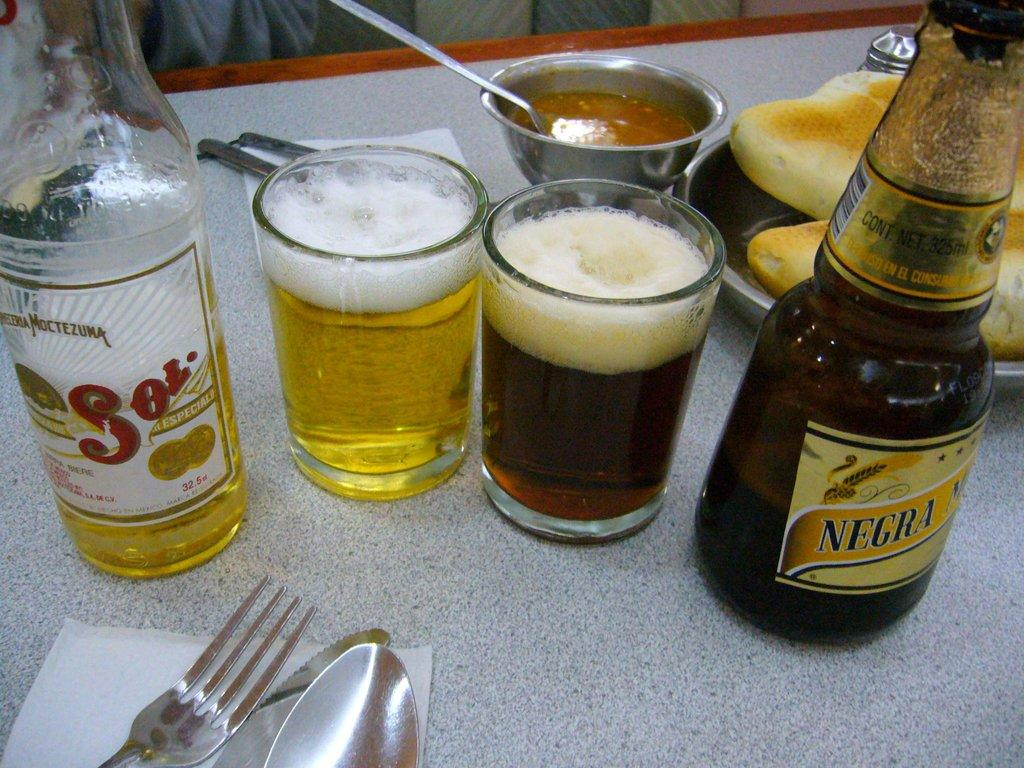What type of objects can be seen on the table in the image? There are bottles, glasses with drinks, forks, spoons, bowls, plates with food items, and tissue paper on the table in the image. What might be used for eating the food items on the plates? Forks and spoons can be used for eating the food items on the plates. What can be used for cleaning or wiping in the image? Tissue paper can be used for cleaning or wiping in the image. What type of bag can be seen on the border of the image? There is no bag present in the image, and there is no border in the image. What type of cup can be seen holding the drinks in the image? There are glasses with drinks in the image, not cups. 